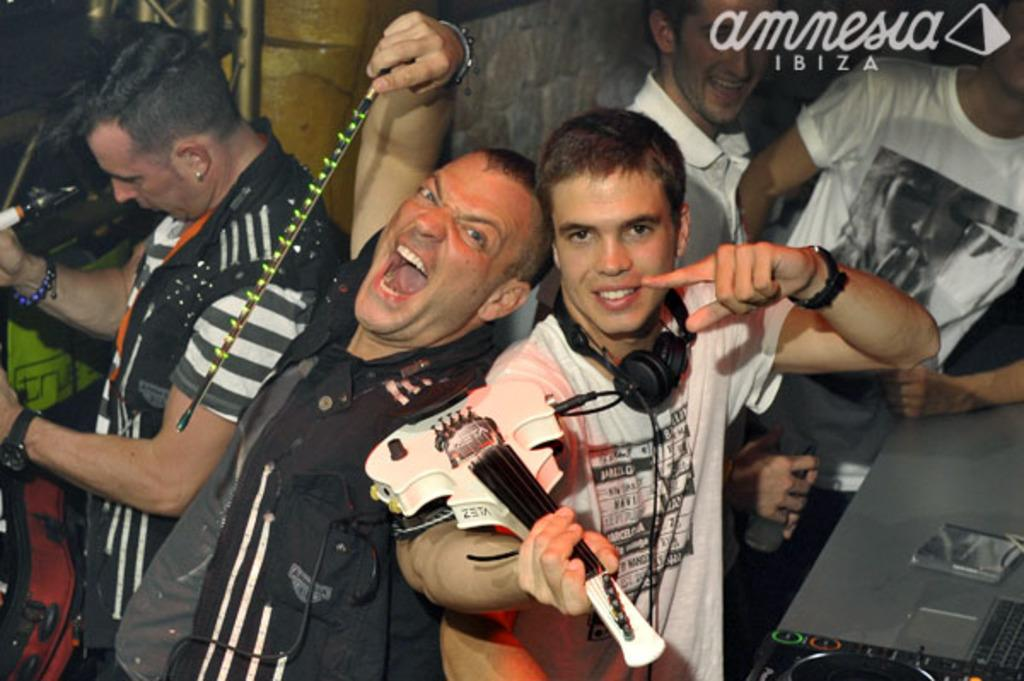What are the people in the image doing? The people in the image are standing. Can you describe any specific objects or instruments being held by the people? One person is holding a guitar. Are there any accessories or clothing items that stand out in the image? A person in the left corner of the image is wearing a watch. What type of farm animals can be seen grazing on the hill in the image? There are no farm animals or hills present in the image. What kind of jewels are being displayed on the person in the right corner of the image? There is no person in the right corner of the image, and no jewels are visible. 